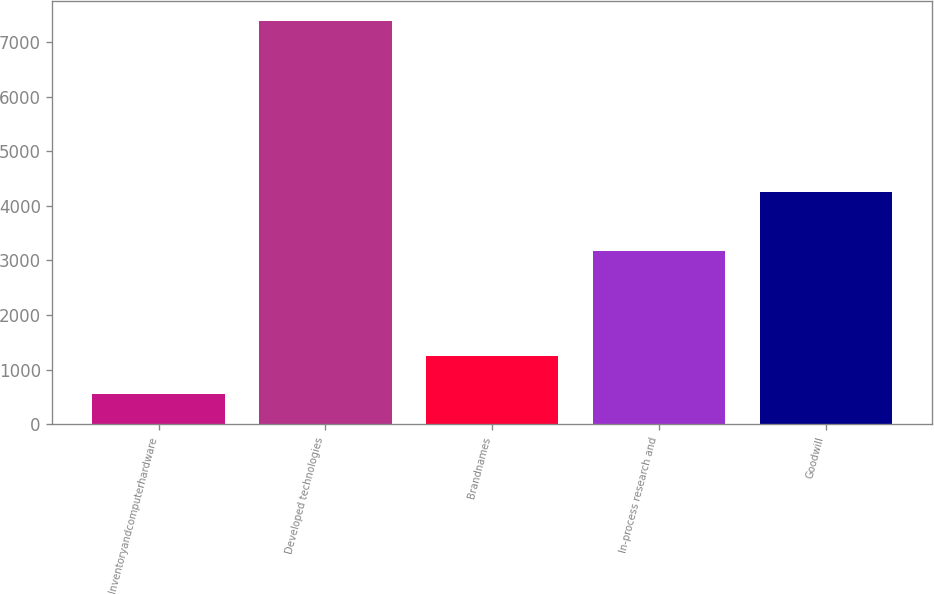Convert chart. <chart><loc_0><loc_0><loc_500><loc_500><bar_chart><fcel>Inventoryandcomputerhardware<fcel>Developed technologies<fcel>Brandnames<fcel>In-process research and<fcel>Goodwill<nl><fcel>558<fcel>7380<fcel>1240.2<fcel>3180<fcel>4262<nl></chart> 